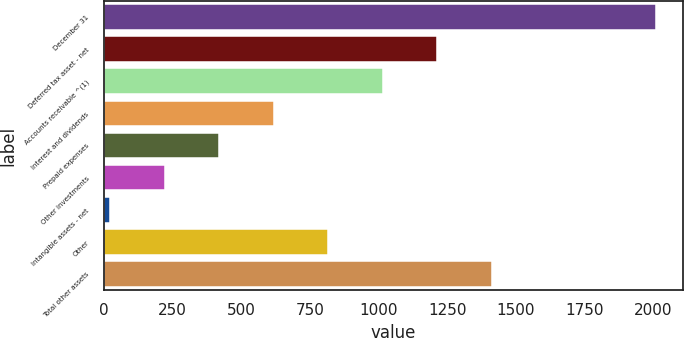Convert chart to OTSL. <chart><loc_0><loc_0><loc_500><loc_500><bar_chart><fcel>December 31<fcel>Deferred tax asset - net<fcel>Accounts receivable ^(1)<fcel>Interest and dividends<fcel>Prepaid expenses<fcel>Other investments<fcel>Intangible assets - net<fcel>Other<fcel>Total other assets<nl><fcel>2008<fcel>1214.4<fcel>1016<fcel>619.2<fcel>420.8<fcel>222.4<fcel>24<fcel>817.6<fcel>1412.8<nl></chart> 